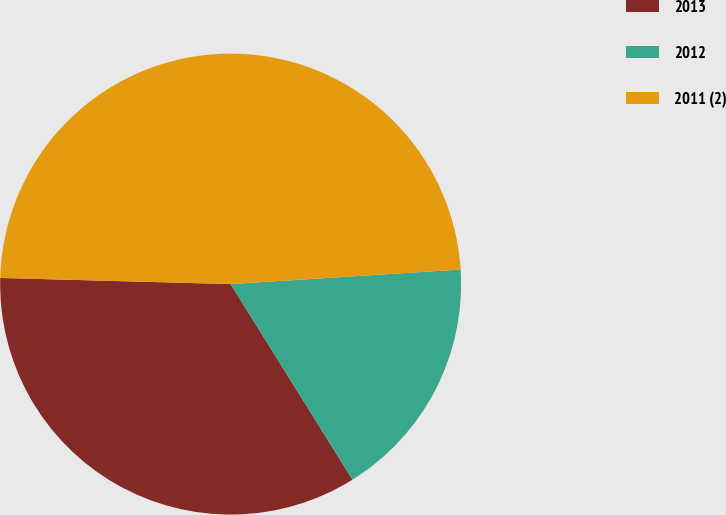Convert chart. <chart><loc_0><loc_0><loc_500><loc_500><pie_chart><fcel>2013<fcel>2012<fcel>2011 (2)<nl><fcel>34.29%<fcel>17.14%<fcel>48.57%<nl></chart> 